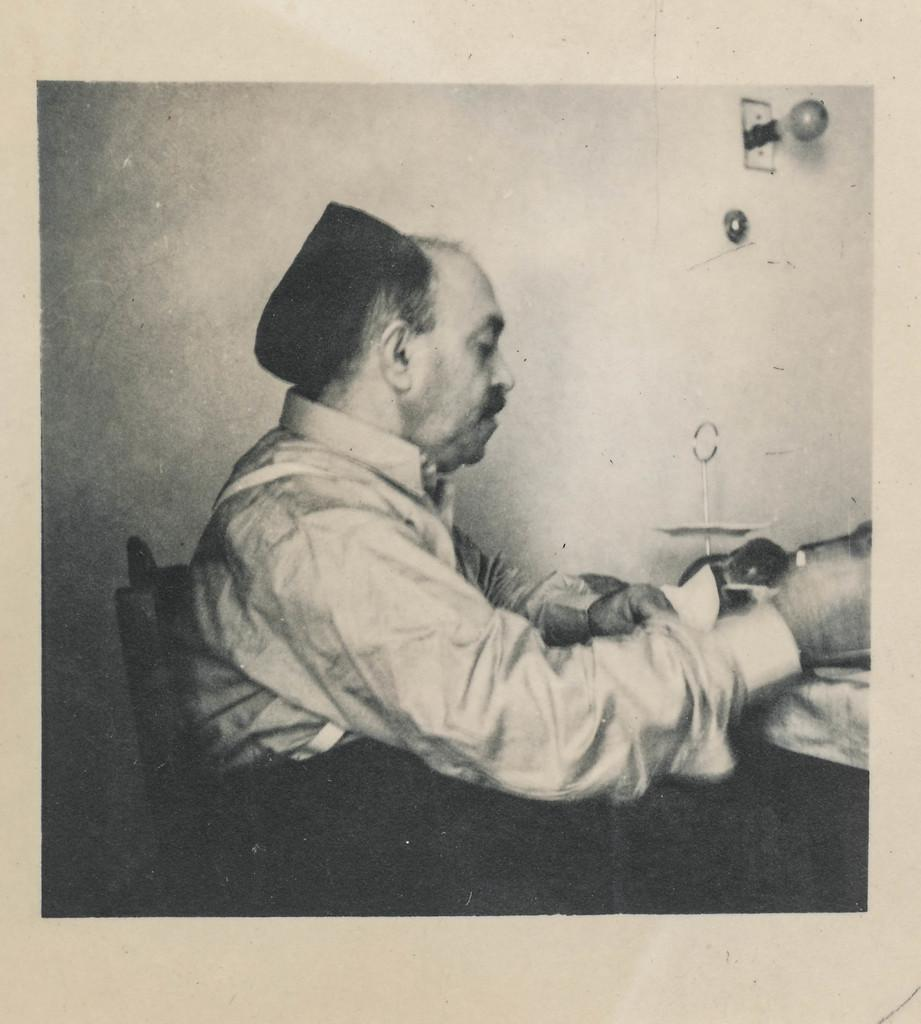What is the color scheme of the poster in the image? The poster is black and white. What is the person in the poster doing? The person is sitting on a chair in the poster. What can be seen behind the person in the poster? There is a wall visible in the image. What is on the wall in the image? There are objects on the wall. What type of treatment is the person in the poster receiving? There is no indication of any treatment being administered in the image; it simply shows a person sitting on a chair. What is the tax rate for the objects on the wall in the image? There is no information about tax rates in the image, as it only shows a poster with a person sitting on a chair and objects on a wall. 